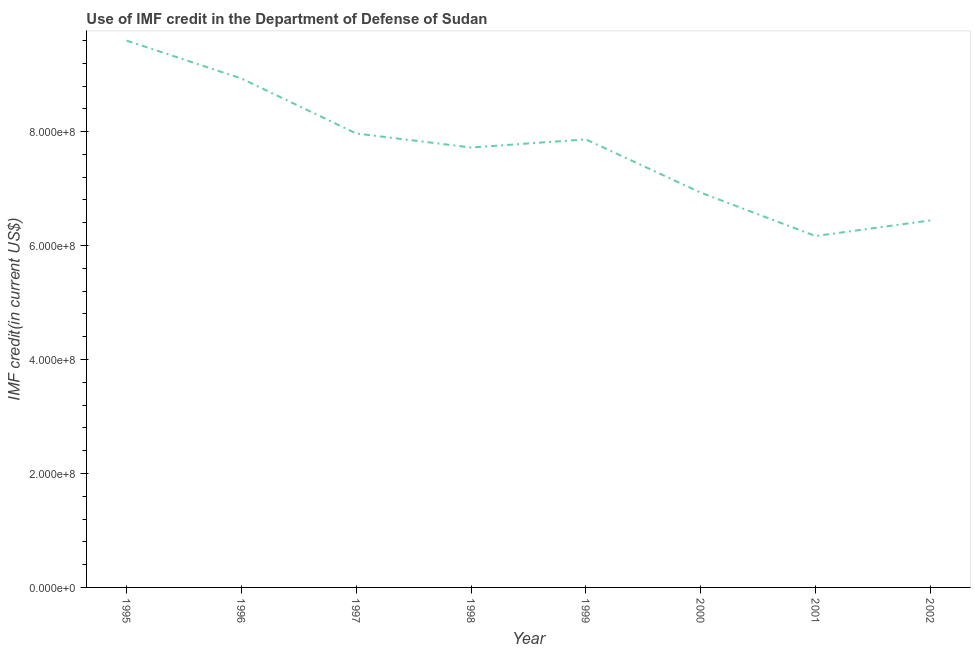What is the use of imf credit in dod in 2001?
Your response must be concise. 6.17e+08. Across all years, what is the maximum use of imf credit in dod?
Your answer should be compact. 9.60e+08. Across all years, what is the minimum use of imf credit in dod?
Make the answer very short. 6.17e+08. In which year was the use of imf credit in dod maximum?
Offer a very short reply. 1995. In which year was the use of imf credit in dod minimum?
Ensure brevity in your answer.  2001. What is the sum of the use of imf credit in dod?
Offer a very short reply. 6.16e+09. What is the difference between the use of imf credit in dod in 2001 and 2002?
Provide a short and direct response. -2.73e+07. What is the average use of imf credit in dod per year?
Ensure brevity in your answer.  7.70e+08. What is the median use of imf credit in dod?
Give a very brief answer. 7.79e+08. In how many years, is the use of imf credit in dod greater than 640000000 US$?
Provide a succinct answer. 7. What is the ratio of the use of imf credit in dod in 1998 to that in 2001?
Ensure brevity in your answer.  1.25. Is the difference between the use of imf credit in dod in 1998 and 2001 greater than the difference between any two years?
Offer a terse response. No. What is the difference between the highest and the second highest use of imf credit in dod?
Your answer should be compact. 6.66e+07. What is the difference between the highest and the lowest use of imf credit in dod?
Your answer should be very brief. 3.43e+08. How many lines are there?
Provide a short and direct response. 1. How many years are there in the graph?
Provide a succinct answer. 8. What is the difference between two consecutive major ticks on the Y-axis?
Give a very brief answer. 2.00e+08. What is the title of the graph?
Offer a very short reply. Use of IMF credit in the Department of Defense of Sudan. What is the label or title of the X-axis?
Your answer should be very brief. Year. What is the label or title of the Y-axis?
Provide a succinct answer. IMF credit(in current US$). What is the IMF credit(in current US$) in 1995?
Provide a short and direct response. 9.60e+08. What is the IMF credit(in current US$) in 1996?
Offer a terse response. 8.93e+08. What is the IMF credit(in current US$) of 1997?
Make the answer very short. 7.97e+08. What is the IMF credit(in current US$) in 1998?
Keep it short and to the point. 7.72e+08. What is the IMF credit(in current US$) of 1999?
Offer a very short reply. 7.86e+08. What is the IMF credit(in current US$) in 2000?
Your answer should be compact. 6.93e+08. What is the IMF credit(in current US$) of 2001?
Give a very brief answer. 6.17e+08. What is the IMF credit(in current US$) in 2002?
Your response must be concise. 6.44e+08. What is the difference between the IMF credit(in current US$) in 1995 and 1996?
Keep it short and to the point. 6.66e+07. What is the difference between the IMF credit(in current US$) in 1995 and 1997?
Offer a terse response. 1.63e+08. What is the difference between the IMF credit(in current US$) in 1995 and 1998?
Provide a succinct answer. 1.88e+08. What is the difference between the IMF credit(in current US$) in 1995 and 1999?
Your answer should be compact. 1.73e+08. What is the difference between the IMF credit(in current US$) in 1995 and 2000?
Provide a succinct answer. 2.67e+08. What is the difference between the IMF credit(in current US$) in 1995 and 2001?
Ensure brevity in your answer.  3.43e+08. What is the difference between the IMF credit(in current US$) in 1995 and 2002?
Your answer should be very brief. 3.16e+08. What is the difference between the IMF credit(in current US$) in 1996 and 1997?
Make the answer very short. 9.64e+07. What is the difference between the IMF credit(in current US$) in 1996 and 1998?
Provide a succinct answer. 1.21e+08. What is the difference between the IMF credit(in current US$) in 1996 and 1999?
Provide a short and direct response. 1.07e+08. What is the difference between the IMF credit(in current US$) in 1996 and 2000?
Offer a terse response. 2.00e+08. What is the difference between the IMF credit(in current US$) in 1996 and 2001?
Ensure brevity in your answer.  2.76e+08. What is the difference between the IMF credit(in current US$) in 1996 and 2002?
Keep it short and to the point. 2.49e+08. What is the difference between the IMF credit(in current US$) in 1997 and 1998?
Your answer should be very brief. 2.46e+07. What is the difference between the IMF credit(in current US$) in 1997 and 1999?
Offer a very short reply. 1.04e+07. What is the difference between the IMF credit(in current US$) in 1997 and 2000?
Your response must be concise. 1.04e+08. What is the difference between the IMF credit(in current US$) in 1997 and 2001?
Your response must be concise. 1.80e+08. What is the difference between the IMF credit(in current US$) in 1997 and 2002?
Keep it short and to the point. 1.53e+08. What is the difference between the IMF credit(in current US$) in 1998 and 1999?
Offer a terse response. -1.43e+07. What is the difference between the IMF credit(in current US$) in 1998 and 2000?
Provide a succinct answer. 7.92e+07. What is the difference between the IMF credit(in current US$) in 1998 and 2001?
Provide a succinct answer. 1.55e+08. What is the difference between the IMF credit(in current US$) in 1998 and 2002?
Give a very brief answer. 1.28e+08. What is the difference between the IMF credit(in current US$) in 1999 and 2000?
Offer a terse response. 9.34e+07. What is the difference between the IMF credit(in current US$) in 1999 and 2001?
Keep it short and to the point. 1.70e+08. What is the difference between the IMF credit(in current US$) in 1999 and 2002?
Your answer should be very brief. 1.42e+08. What is the difference between the IMF credit(in current US$) in 2000 and 2001?
Give a very brief answer. 7.62e+07. What is the difference between the IMF credit(in current US$) in 2000 and 2002?
Keep it short and to the point. 4.88e+07. What is the difference between the IMF credit(in current US$) in 2001 and 2002?
Offer a very short reply. -2.73e+07. What is the ratio of the IMF credit(in current US$) in 1995 to that in 1996?
Give a very brief answer. 1.07. What is the ratio of the IMF credit(in current US$) in 1995 to that in 1997?
Ensure brevity in your answer.  1.21. What is the ratio of the IMF credit(in current US$) in 1995 to that in 1998?
Ensure brevity in your answer.  1.24. What is the ratio of the IMF credit(in current US$) in 1995 to that in 1999?
Give a very brief answer. 1.22. What is the ratio of the IMF credit(in current US$) in 1995 to that in 2000?
Provide a short and direct response. 1.39. What is the ratio of the IMF credit(in current US$) in 1995 to that in 2001?
Offer a very short reply. 1.56. What is the ratio of the IMF credit(in current US$) in 1995 to that in 2002?
Provide a succinct answer. 1.49. What is the ratio of the IMF credit(in current US$) in 1996 to that in 1997?
Provide a succinct answer. 1.12. What is the ratio of the IMF credit(in current US$) in 1996 to that in 1998?
Offer a terse response. 1.16. What is the ratio of the IMF credit(in current US$) in 1996 to that in 1999?
Your answer should be very brief. 1.14. What is the ratio of the IMF credit(in current US$) in 1996 to that in 2000?
Offer a terse response. 1.29. What is the ratio of the IMF credit(in current US$) in 1996 to that in 2001?
Provide a succinct answer. 1.45. What is the ratio of the IMF credit(in current US$) in 1996 to that in 2002?
Give a very brief answer. 1.39. What is the ratio of the IMF credit(in current US$) in 1997 to that in 1998?
Your response must be concise. 1.03. What is the ratio of the IMF credit(in current US$) in 1997 to that in 2000?
Ensure brevity in your answer.  1.15. What is the ratio of the IMF credit(in current US$) in 1997 to that in 2001?
Offer a terse response. 1.29. What is the ratio of the IMF credit(in current US$) in 1997 to that in 2002?
Offer a terse response. 1.24. What is the ratio of the IMF credit(in current US$) in 1998 to that in 2000?
Offer a terse response. 1.11. What is the ratio of the IMF credit(in current US$) in 1998 to that in 2001?
Your answer should be compact. 1.25. What is the ratio of the IMF credit(in current US$) in 1998 to that in 2002?
Your response must be concise. 1.2. What is the ratio of the IMF credit(in current US$) in 1999 to that in 2000?
Give a very brief answer. 1.14. What is the ratio of the IMF credit(in current US$) in 1999 to that in 2001?
Offer a very short reply. 1.27. What is the ratio of the IMF credit(in current US$) in 1999 to that in 2002?
Your answer should be very brief. 1.22. What is the ratio of the IMF credit(in current US$) in 2000 to that in 2001?
Give a very brief answer. 1.12. What is the ratio of the IMF credit(in current US$) in 2000 to that in 2002?
Your answer should be compact. 1.08. What is the ratio of the IMF credit(in current US$) in 2001 to that in 2002?
Your answer should be compact. 0.96. 